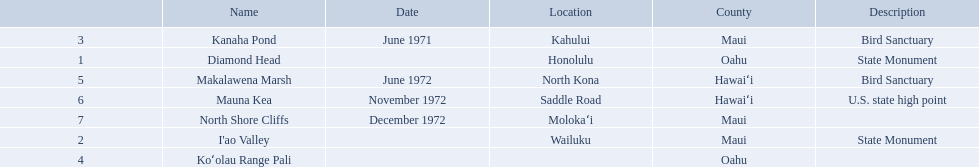What are all of the national natural landmarks in hawaii? Diamond Head, I'ao Valley, Kanaha Pond, Koʻolau Range Pali, Makalawena Marsh, Mauna Kea, North Shore Cliffs. Which ones of those national natural landmarks in hawaii are in the county of hawai'i? Makalawena Marsh, Mauna Kea. Which is the only national natural landmark in hawaii that is also a u.s. state high point? Mauna Kea. 